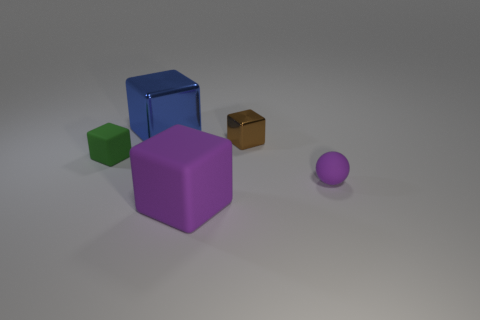There is another object that is the same color as the big matte object; what is its shape?
Provide a succinct answer. Sphere. There is a green thing; does it have the same shape as the tiny rubber thing right of the green cube?
Ensure brevity in your answer.  No. There is a matte object that is both behind the purple cube and on the left side of the brown thing; what color is it?
Give a very brief answer. Green. Is there a small yellow matte block?
Provide a succinct answer. No. Are there the same number of large blue things that are behind the large blue block and green metal cylinders?
Make the answer very short. Yes. What number of other objects are there of the same shape as the tiny purple thing?
Offer a terse response. 0. The small purple rubber object has what shape?
Your answer should be very brief. Sphere. Is the material of the large blue thing the same as the purple sphere?
Your response must be concise. No. Are there the same number of purple matte balls that are behind the small purple rubber object and big purple blocks behind the tiny green object?
Keep it short and to the point. Yes. There is a tiny purple sphere that is to the right of the metal block behind the tiny brown shiny cube; is there a brown metal thing to the left of it?
Provide a short and direct response. Yes. 